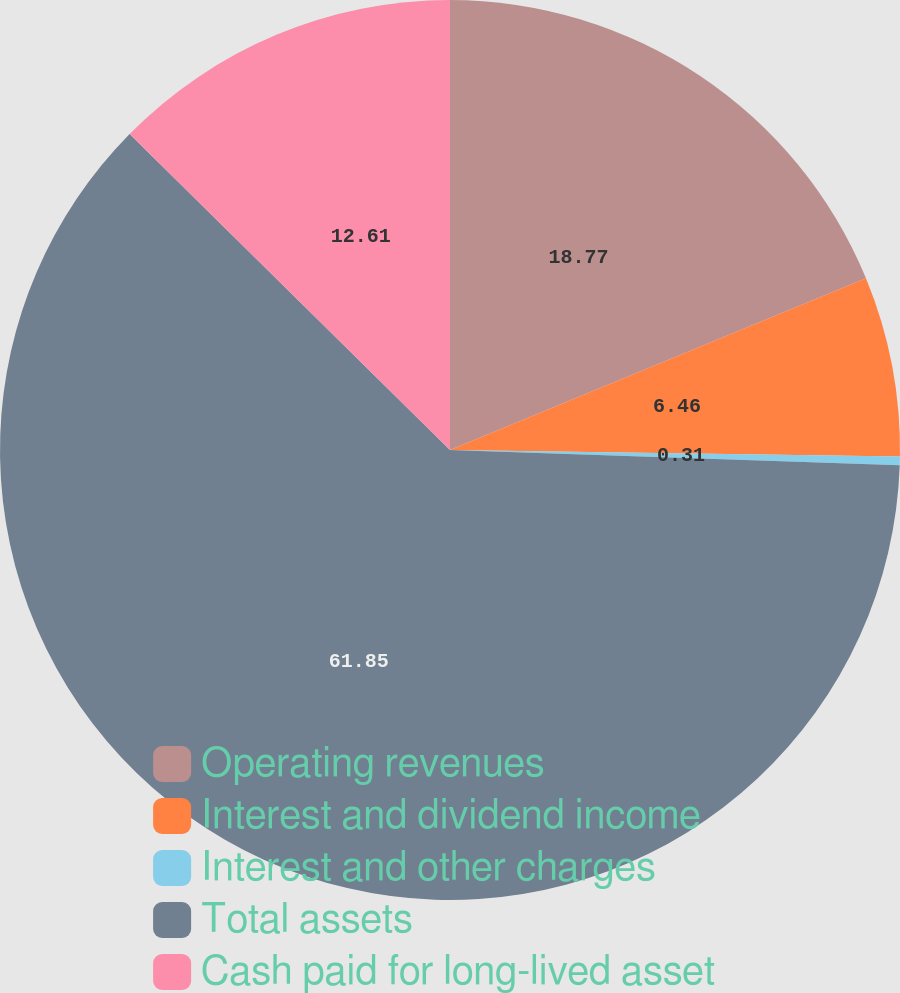Convert chart. <chart><loc_0><loc_0><loc_500><loc_500><pie_chart><fcel>Operating revenues<fcel>Interest and dividend income<fcel>Interest and other charges<fcel>Total assets<fcel>Cash paid for long-lived asset<nl><fcel>18.77%<fcel>6.46%<fcel>0.31%<fcel>61.85%<fcel>12.61%<nl></chart> 